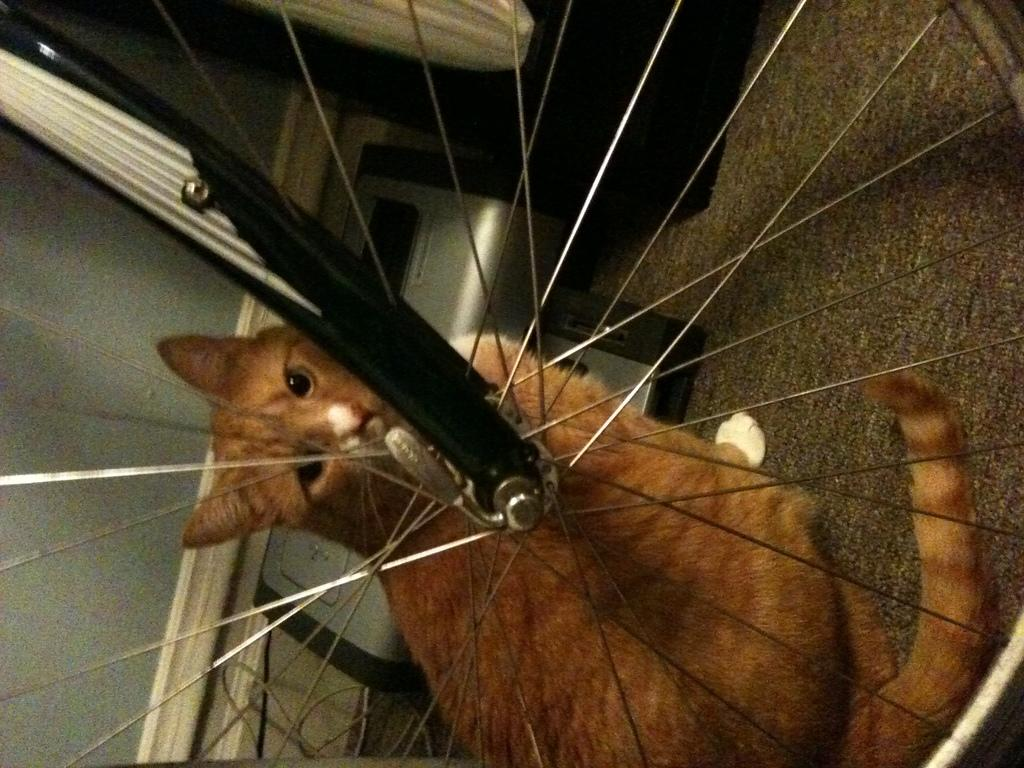What type of animal is in the image? There is a cat in the image. Where is the cat located in relation to the bicycle wheel? The cat is sitting behind a bicycle wheel. What can be seen in the background of the image? There is a wall visible in the background of the image. How many brothers does the cat have in the image? There is no information about the cat's brothers in the image. What type of cable is connected to the bicycle wheel in the image? There is no cable connected to the bicycle wheel in the image. 